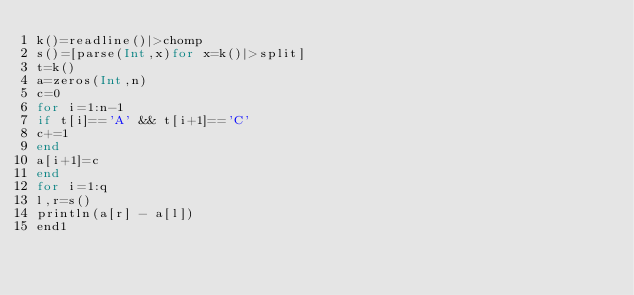Convert code to text. <code><loc_0><loc_0><loc_500><loc_500><_Julia_>k()=readline()|>chomp
s()=[parse(Int,x)for x=k()|>split]
t=k()
a=zeros(Int,n)
c=0
for i=1:n-1
if t[i]=='A' && t[i+1]=='C'
c+=1
end
a[i+1]=c
end
for i=1:q
l,r=s()
println(a[r] - a[l])
end1</code> 